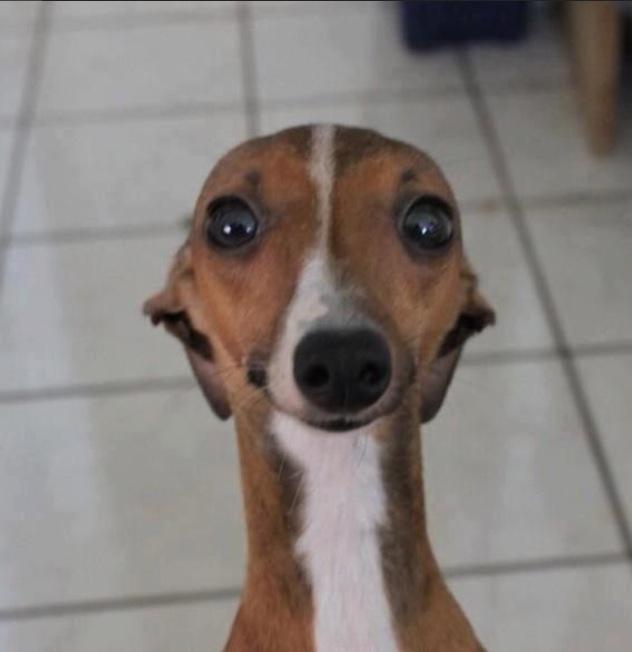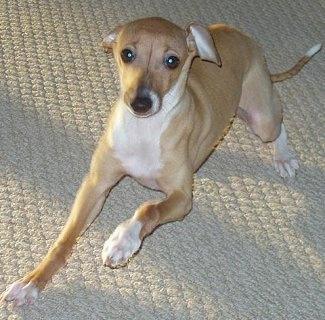The first image is the image on the left, the second image is the image on the right. Assess this claim about the two images: "In one of the images the dog is on a tile floor.". Correct or not? Answer yes or no. Yes. The first image is the image on the left, the second image is the image on the right. Examine the images to the left and right. Is the description "Each image shows exactly one non-standing hound, and the combined images show at least one hound reclining with front paws extended in front of its body." accurate? Answer yes or no. Yes. 